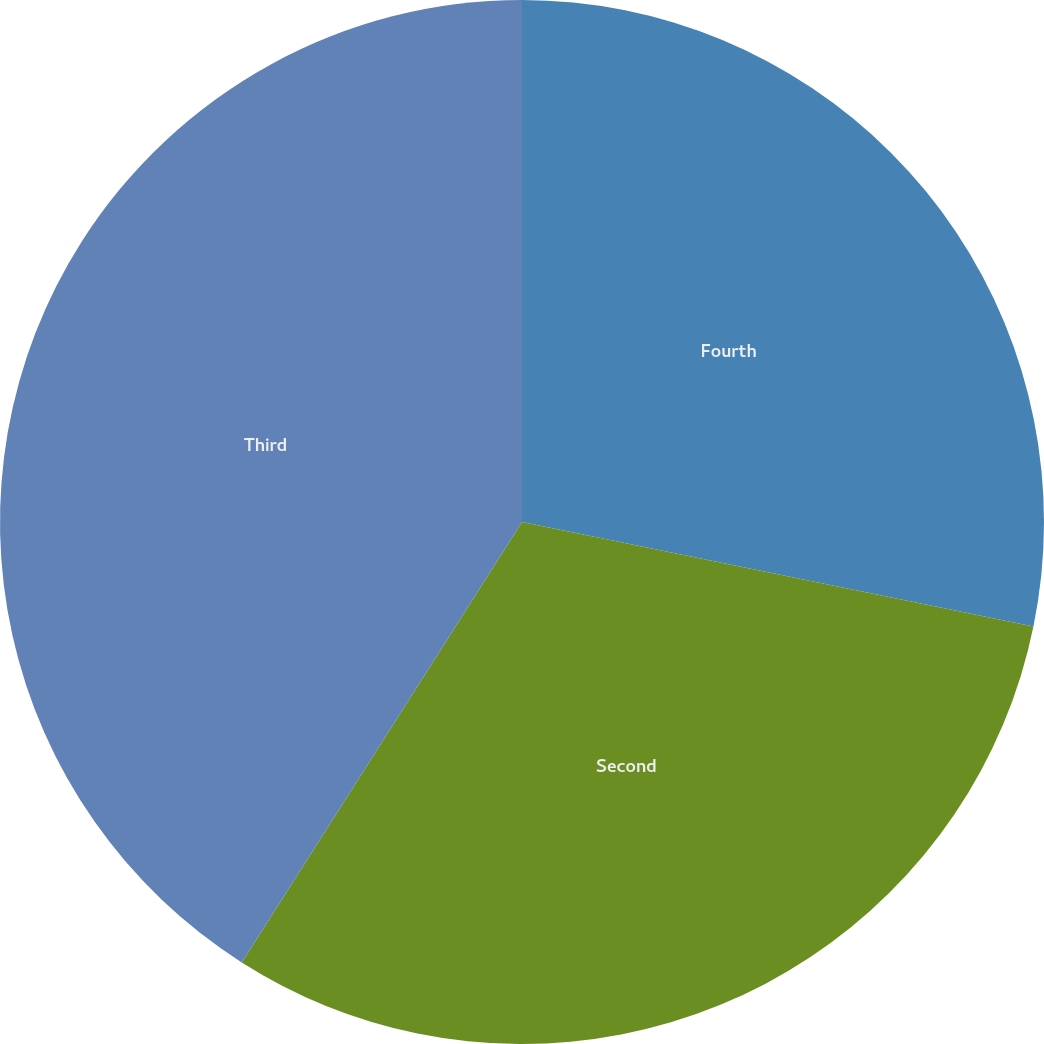Convert chart to OTSL. <chart><loc_0><loc_0><loc_500><loc_500><pie_chart><fcel>Fourth<fcel>Second<fcel>Third<nl><fcel>28.21%<fcel>30.81%<fcel>40.98%<nl></chart> 